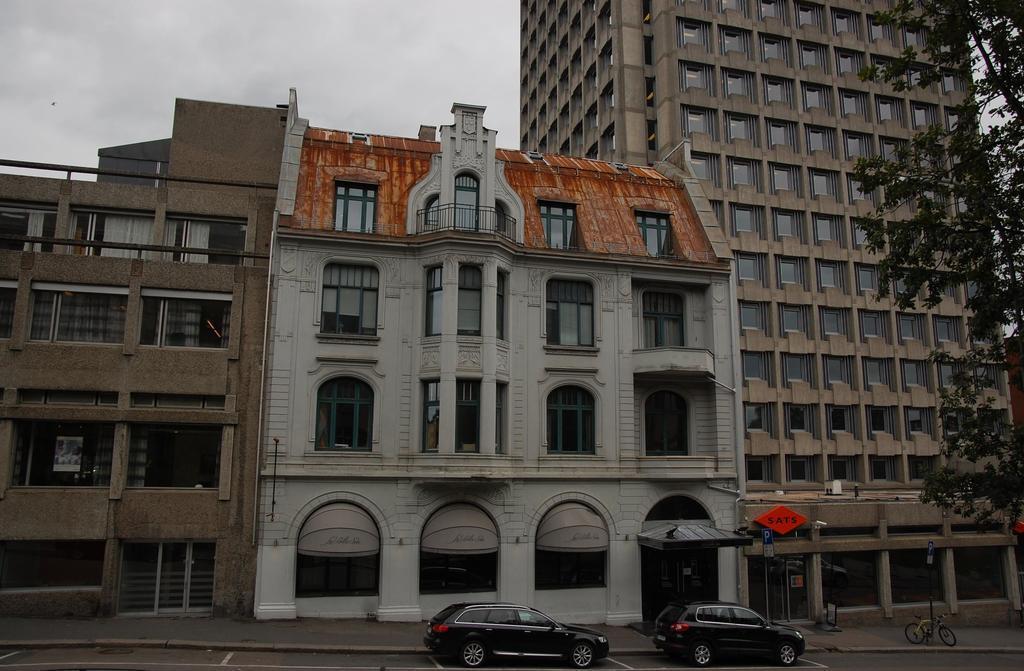What type of structures are present in the image? There are buildings in the image. What other natural or man-made elements can be seen in the image? There are trees and poles visible in the image. What is happening on the road at the bottom of the image? There are vehicles on the road at the bottom of the image. What is visible at the top of the image? The sky is visible at the top of the image. What type of prison can be seen in the image? There is no prison present in the image. What kind of home is visible in the image? There is no home present in the image. 